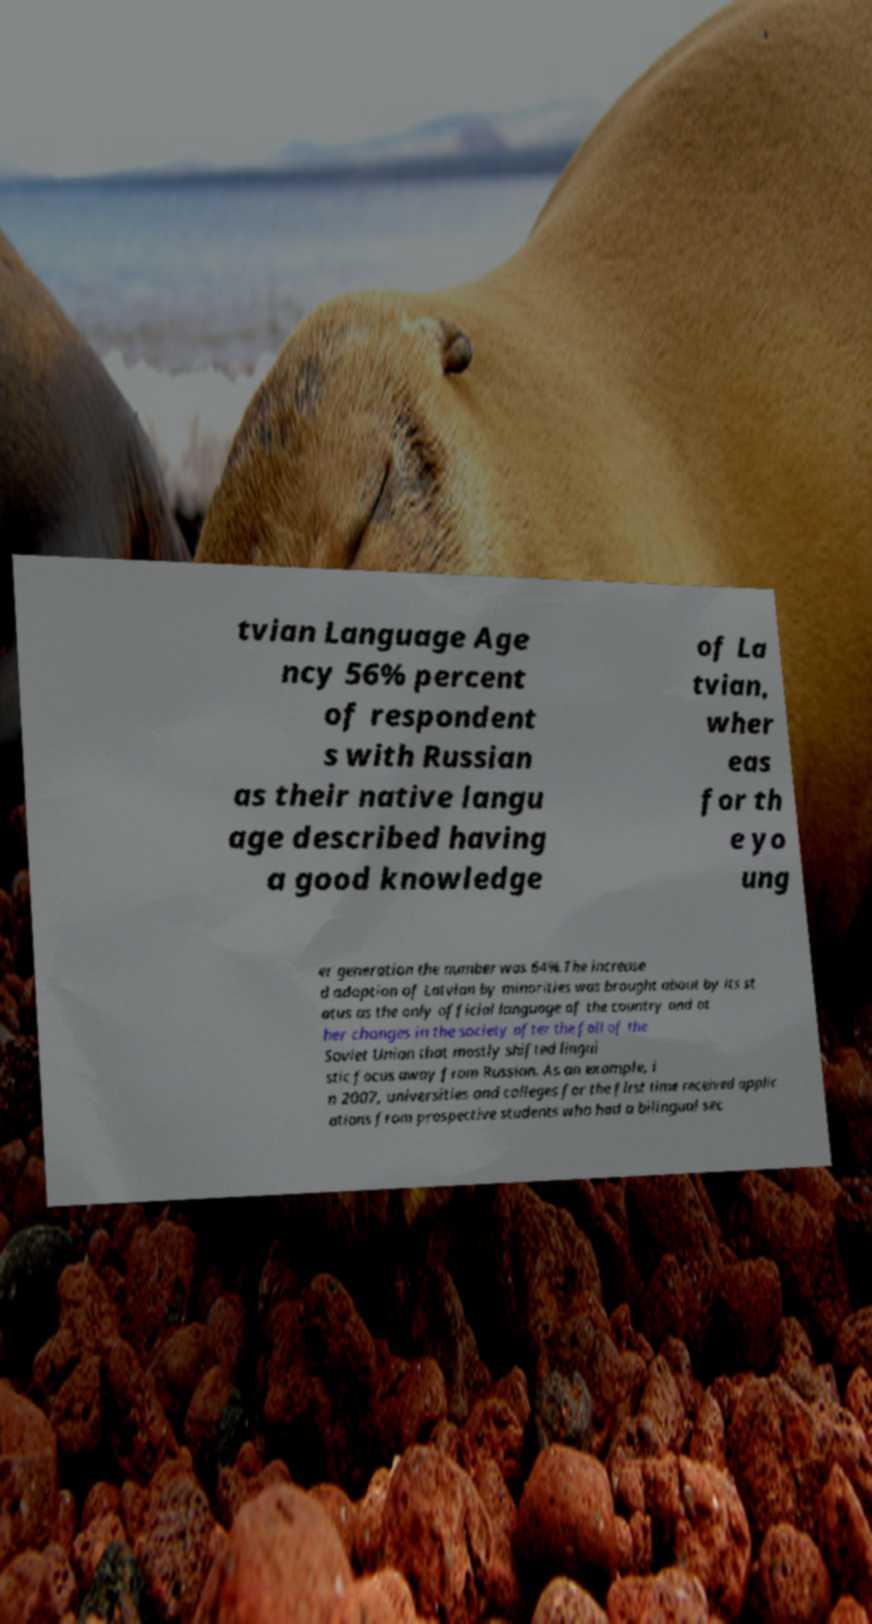Can you accurately transcribe the text from the provided image for me? tvian Language Age ncy 56% percent of respondent s with Russian as their native langu age described having a good knowledge of La tvian, wher eas for th e yo ung er generation the number was 64%.The increase d adoption of Latvian by minorities was brought about by its st atus as the only official language of the country and ot her changes in the society after the fall of the Soviet Union that mostly shifted lingui stic focus away from Russian. As an example, i n 2007, universities and colleges for the first time received applic ations from prospective students who had a bilingual sec 